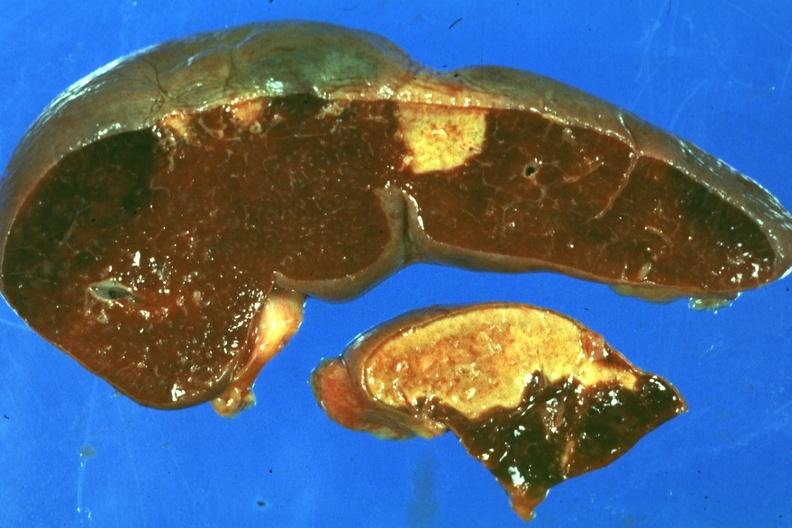what does this image show?
Answer the question using a single word or phrase. Typical lesion about a week or more of age 